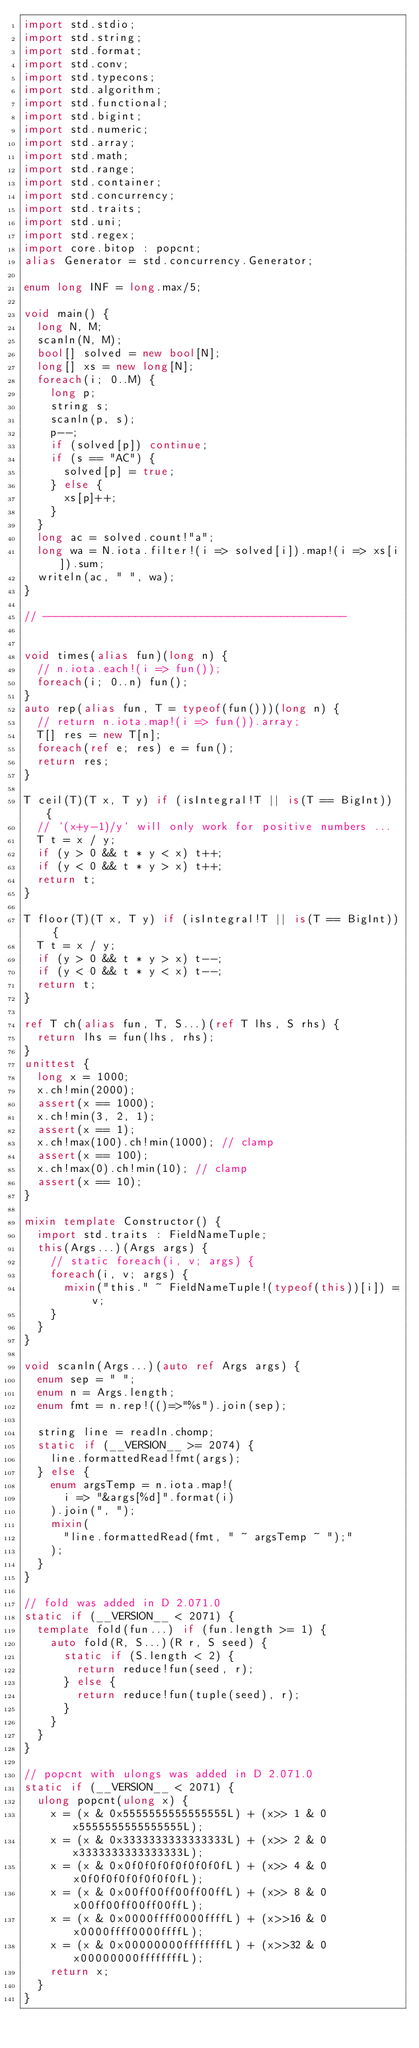Convert code to text. <code><loc_0><loc_0><loc_500><loc_500><_D_>import std.stdio;
import std.string;
import std.format;
import std.conv;
import std.typecons;
import std.algorithm;
import std.functional;
import std.bigint;
import std.numeric;
import std.array;
import std.math;
import std.range;
import std.container;
import std.concurrency;
import std.traits;
import std.uni;
import std.regex;
import core.bitop : popcnt;
alias Generator = std.concurrency.Generator;

enum long INF = long.max/5;

void main() {
  long N, M;
  scanln(N, M);
  bool[] solved = new bool[N];
  long[] xs = new long[N];
  foreach(i; 0..M) {
    long p;
    string s;
    scanln(p, s);
    p--;
    if (solved[p]) continue;
    if (s == "AC") {
      solved[p] = true;
    } else {
      xs[p]++;
    }
  }
  long ac = solved.count!"a";
  long wa = N.iota.filter!(i => solved[i]).map!(i => xs[i]).sum;
  writeln(ac, " ", wa);
}

// ----------------------------------------------


void times(alias fun)(long n) {
  // n.iota.each!(i => fun());
  foreach(i; 0..n) fun();
}
auto rep(alias fun, T = typeof(fun()))(long n) {
  // return n.iota.map!(i => fun()).array;
  T[] res = new T[n];
  foreach(ref e; res) e = fun();
  return res;
}

T ceil(T)(T x, T y) if (isIntegral!T || is(T == BigInt)) {
  // `(x+y-1)/y` will only work for positive numbers ...
  T t = x / y;
  if (y > 0 && t * y < x) t++;
  if (y < 0 && t * y > x) t++;
  return t;
}

T floor(T)(T x, T y) if (isIntegral!T || is(T == BigInt)) {
  T t = x / y;
  if (y > 0 && t * y > x) t--;
  if (y < 0 && t * y < x) t--;
  return t;
}

ref T ch(alias fun, T, S...)(ref T lhs, S rhs) {
  return lhs = fun(lhs, rhs);
}
unittest {
  long x = 1000;
  x.ch!min(2000);
  assert(x == 1000);
  x.ch!min(3, 2, 1);
  assert(x == 1);
  x.ch!max(100).ch!min(1000); // clamp
  assert(x == 100);
  x.ch!max(0).ch!min(10); // clamp
  assert(x == 10);
}

mixin template Constructor() {
  import std.traits : FieldNameTuple;
  this(Args...)(Args args) {
    // static foreach(i, v; args) {
    foreach(i, v; args) {
      mixin("this." ~ FieldNameTuple!(typeof(this))[i]) = v;
    }
  }
}

void scanln(Args...)(auto ref Args args) {
  enum sep = " ";
  enum n = Args.length;
  enum fmt = n.rep!(()=>"%s").join(sep);

  string line = readln.chomp;
  static if (__VERSION__ >= 2074) {
    line.formattedRead!fmt(args);
  } else {
    enum argsTemp = n.iota.map!(
      i => "&args[%d]".format(i)
    ).join(", ");
    mixin(
      "line.formattedRead(fmt, " ~ argsTemp ~ ");"
    );
  }
}

// fold was added in D 2.071.0
static if (__VERSION__ < 2071) {
  template fold(fun...) if (fun.length >= 1) {
    auto fold(R, S...)(R r, S seed) {
      static if (S.length < 2) {
        return reduce!fun(seed, r);
      } else {
        return reduce!fun(tuple(seed), r);
      }
    }
  }
}

// popcnt with ulongs was added in D 2.071.0
static if (__VERSION__ < 2071) {
  ulong popcnt(ulong x) {
    x = (x & 0x5555555555555555L) + (x>> 1 & 0x5555555555555555L);
    x = (x & 0x3333333333333333L) + (x>> 2 & 0x3333333333333333L);
    x = (x & 0x0f0f0f0f0f0f0f0fL) + (x>> 4 & 0x0f0f0f0f0f0f0f0fL);
    x = (x & 0x00ff00ff00ff00ffL) + (x>> 8 & 0x00ff00ff00ff00ffL);
    x = (x & 0x0000ffff0000ffffL) + (x>>16 & 0x0000ffff0000ffffL);
    x = (x & 0x00000000ffffffffL) + (x>>32 & 0x00000000ffffffffL);
    return x;
  }
}
</code> 